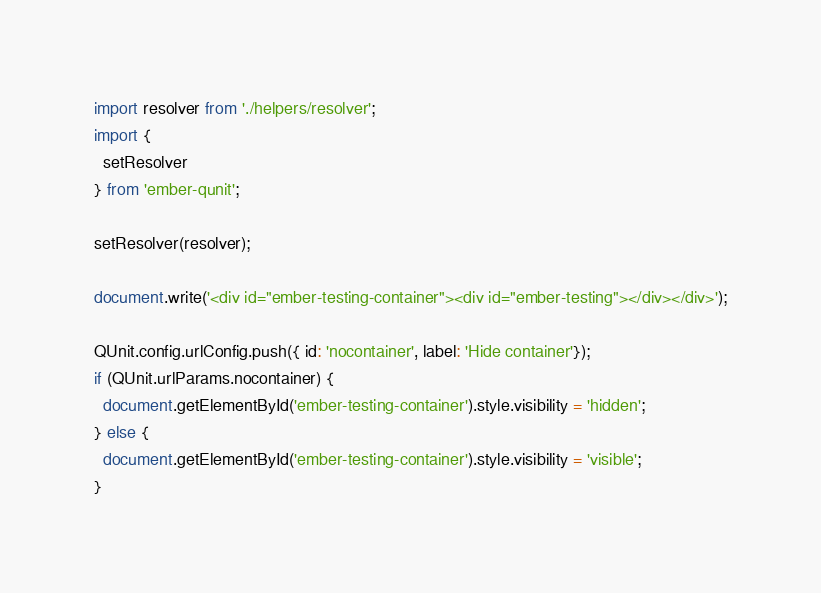Convert code to text. <code><loc_0><loc_0><loc_500><loc_500><_JavaScript_>import resolver from './helpers/resolver';
import {
  setResolver
} from 'ember-qunit';

setResolver(resolver);

document.write('<div id="ember-testing-container"><div id="ember-testing"></div></div>');

QUnit.config.urlConfig.push({ id: 'nocontainer', label: 'Hide container'});
if (QUnit.urlParams.nocontainer) {
  document.getElementById('ember-testing-container').style.visibility = 'hidden';
} else {
  document.getElementById('ember-testing-container').style.visibility = 'visible';
}
</code> 